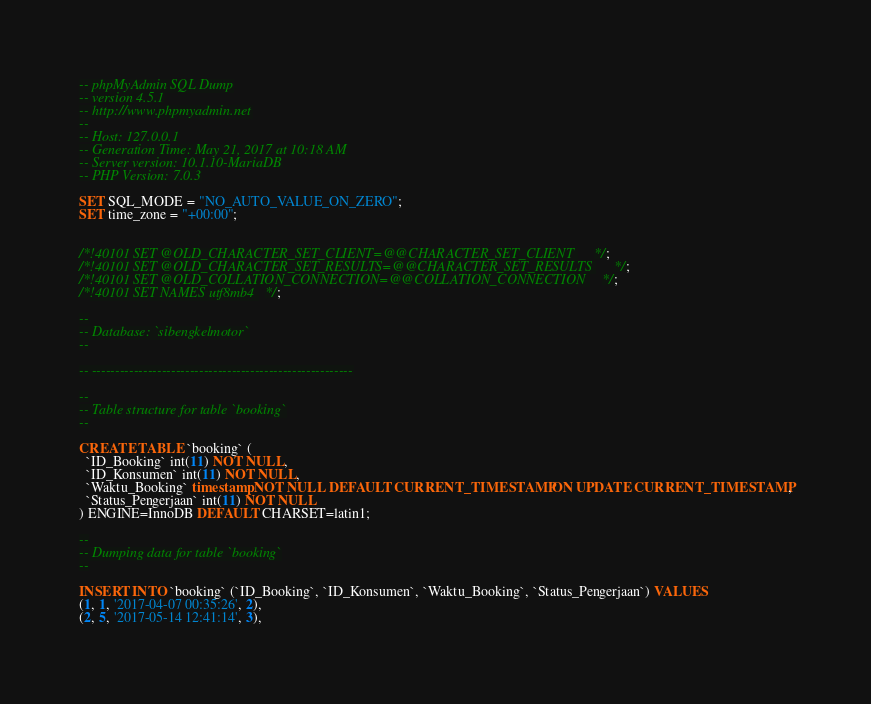<code> <loc_0><loc_0><loc_500><loc_500><_SQL_>-- phpMyAdmin SQL Dump
-- version 4.5.1
-- http://www.phpmyadmin.net
--
-- Host: 127.0.0.1
-- Generation Time: May 21, 2017 at 10:18 AM
-- Server version: 10.1.10-MariaDB
-- PHP Version: 7.0.3

SET SQL_MODE = "NO_AUTO_VALUE_ON_ZERO";
SET time_zone = "+00:00";


/*!40101 SET @OLD_CHARACTER_SET_CLIENT=@@CHARACTER_SET_CLIENT */;
/*!40101 SET @OLD_CHARACTER_SET_RESULTS=@@CHARACTER_SET_RESULTS */;
/*!40101 SET @OLD_COLLATION_CONNECTION=@@COLLATION_CONNECTION */;
/*!40101 SET NAMES utf8mb4 */;

--
-- Database: `sibengkelmotor`
--

-- --------------------------------------------------------

--
-- Table structure for table `booking`
--

CREATE TABLE `booking` (
  `ID_Booking` int(11) NOT NULL,
  `ID_Konsumen` int(11) NOT NULL,
  `Waktu_Booking` timestamp NOT NULL DEFAULT CURRENT_TIMESTAMP ON UPDATE CURRENT_TIMESTAMP,
  `Status_Pengerjaan` int(11) NOT NULL
) ENGINE=InnoDB DEFAULT CHARSET=latin1;

--
-- Dumping data for table `booking`
--

INSERT INTO `booking` (`ID_Booking`, `ID_Konsumen`, `Waktu_Booking`, `Status_Pengerjaan`) VALUES
(1, 1, '2017-04-07 00:35:26', 2),
(2, 5, '2017-05-14 12:41:14', 3),</code> 